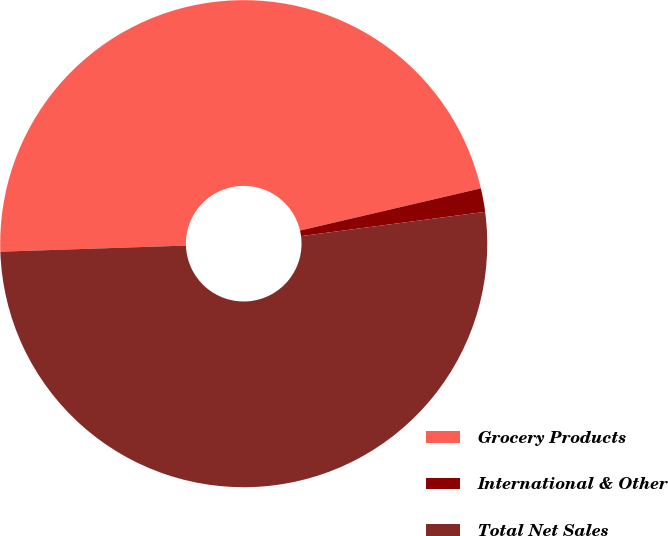Convert chart to OTSL. <chart><loc_0><loc_0><loc_500><loc_500><pie_chart><fcel>Grocery Products<fcel>International & Other<fcel>Total Net Sales<nl><fcel>46.88%<fcel>1.56%<fcel>51.57%<nl></chart> 